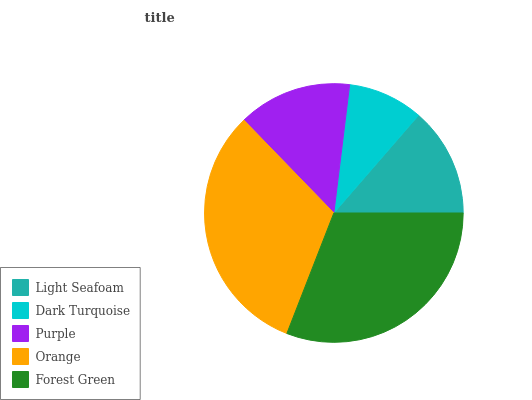Is Dark Turquoise the minimum?
Answer yes or no. Yes. Is Orange the maximum?
Answer yes or no. Yes. Is Purple the minimum?
Answer yes or no. No. Is Purple the maximum?
Answer yes or no. No. Is Purple greater than Dark Turquoise?
Answer yes or no. Yes. Is Dark Turquoise less than Purple?
Answer yes or no. Yes. Is Dark Turquoise greater than Purple?
Answer yes or no. No. Is Purple less than Dark Turquoise?
Answer yes or no. No. Is Purple the high median?
Answer yes or no. Yes. Is Purple the low median?
Answer yes or no. Yes. Is Orange the high median?
Answer yes or no. No. Is Forest Green the low median?
Answer yes or no. No. 